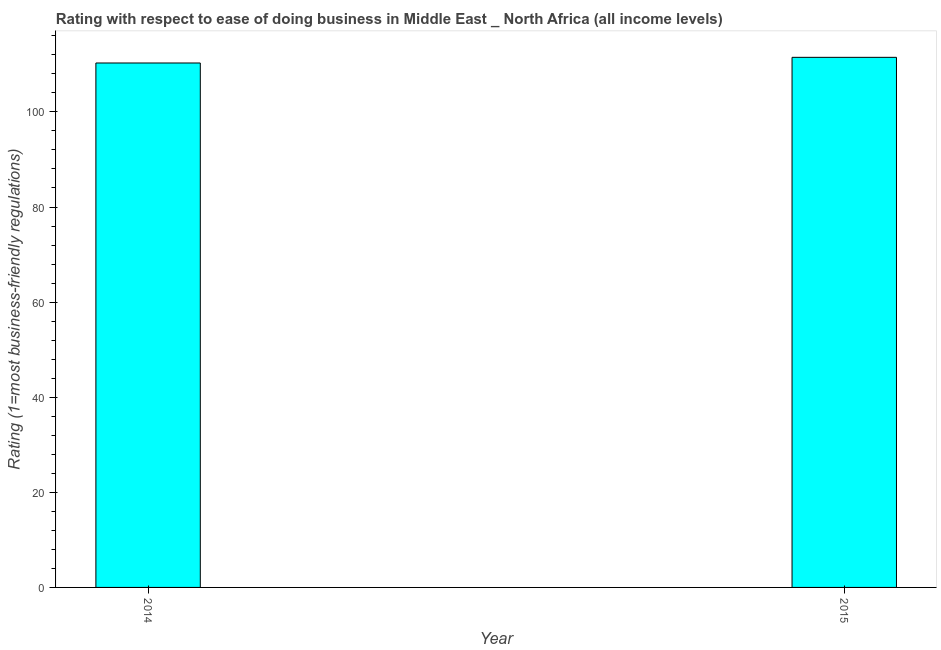What is the title of the graph?
Keep it short and to the point. Rating with respect to ease of doing business in Middle East _ North Africa (all income levels). What is the label or title of the X-axis?
Ensure brevity in your answer.  Year. What is the label or title of the Y-axis?
Keep it short and to the point. Rating (1=most business-friendly regulations). What is the ease of doing business index in 2014?
Provide a short and direct response. 110.29. Across all years, what is the maximum ease of doing business index?
Provide a succinct answer. 111.48. Across all years, what is the minimum ease of doing business index?
Offer a very short reply. 110.29. In which year was the ease of doing business index maximum?
Give a very brief answer. 2015. In which year was the ease of doing business index minimum?
Provide a short and direct response. 2014. What is the sum of the ease of doing business index?
Provide a short and direct response. 221.76. What is the difference between the ease of doing business index in 2014 and 2015?
Your answer should be very brief. -1.19. What is the average ease of doing business index per year?
Provide a short and direct response. 110.88. What is the median ease of doing business index?
Offer a terse response. 110.88. In how many years, is the ease of doing business index greater than 84 ?
Your answer should be very brief. 2. Do a majority of the years between 2015 and 2014 (inclusive) have ease of doing business index greater than 40 ?
Ensure brevity in your answer.  No. Are the values on the major ticks of Y-axis written in scientific E-notation?
Give a very brief answer. No. What is the Rating (1=most business-friendly regulations) in 2014?
Give a very brief answer. 110.29. What is the Rating (1=most business-friendly regulations) in 2015?
Offer a terse response. 111.48. What is the difference between the Rating (1=most business-friendly regulations) in 2014 and 2015?
Offer a terse response. -1.19. What is the ratio of the Rating (1=most business-friendly regulations) in 2014 to that in 2015?
Provide a succinct answer. 0.99. 